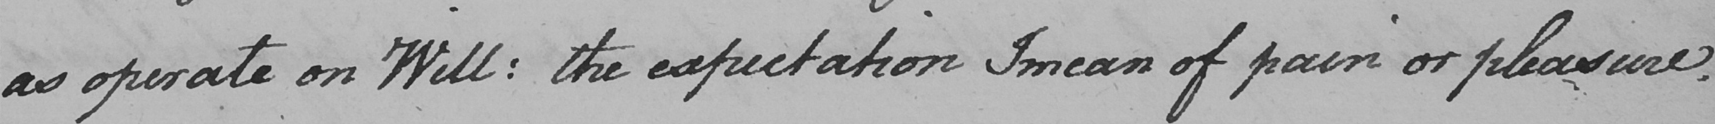Please transcribe the handwritten text in this image. as operate on Will :  the expectation I mean of pain or pleasure . 